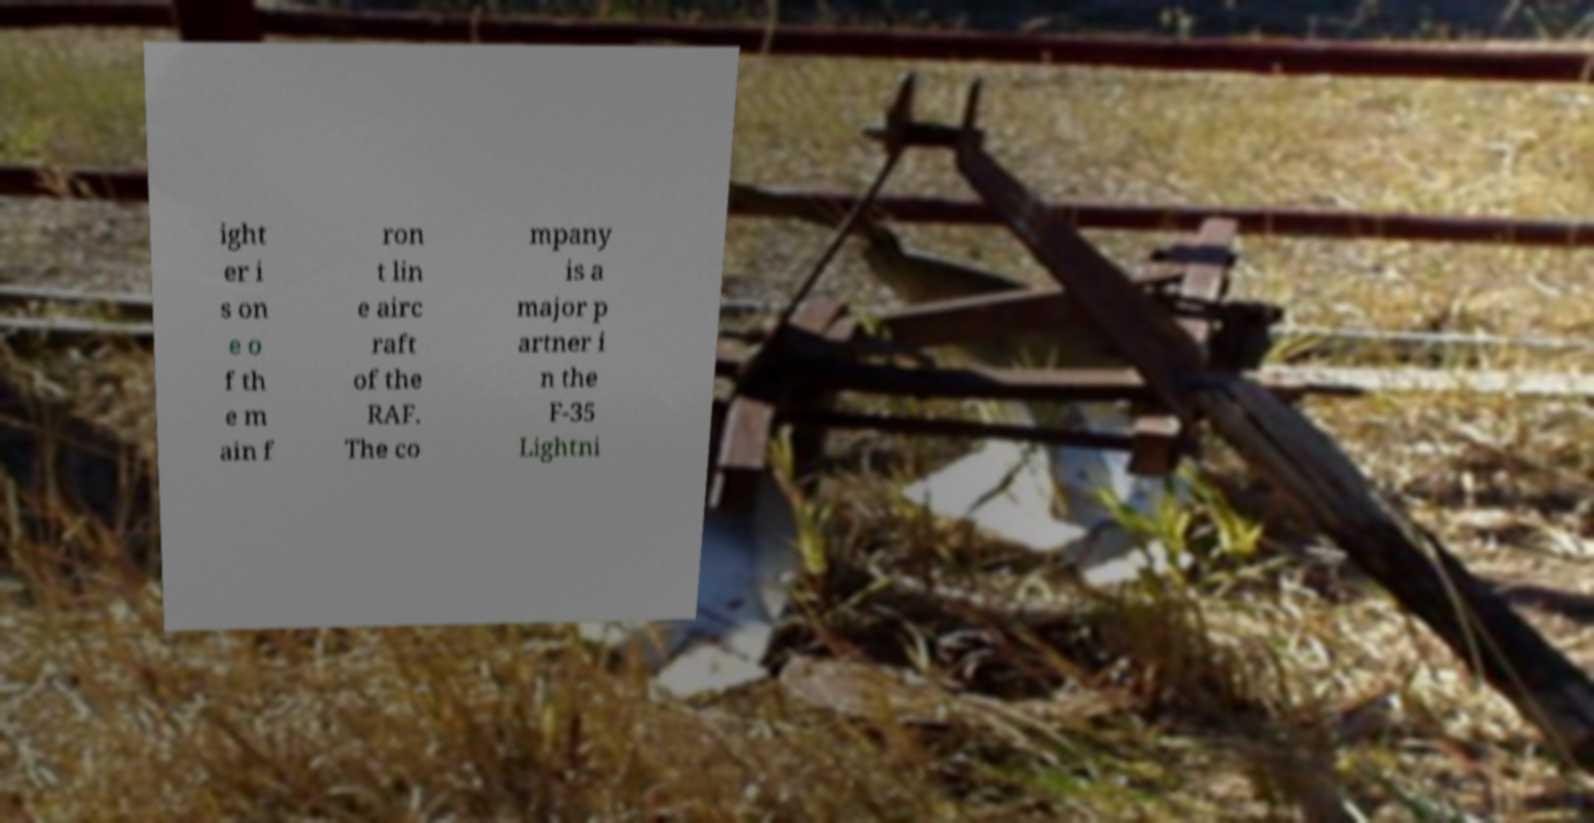Please read and relay the text visible in this image. What does it say? ight er i s on e o f th e m ain f ron t lin e airc raft of the RAF. The co mpany is a major p artner i n the F-35 Lightni 